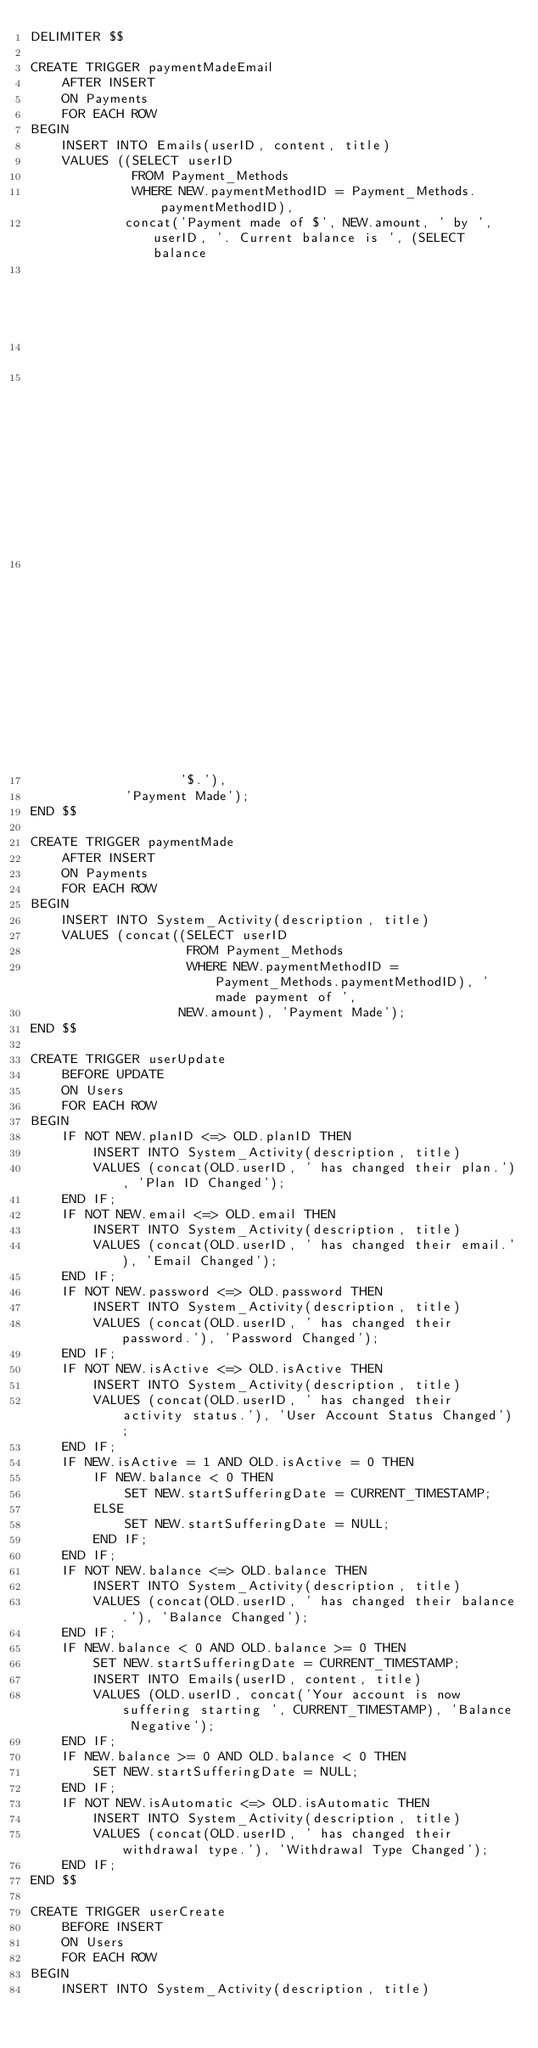<code> <loc_0><loc_0><loc_500><loc_500><_SQL_>DELIMITER $$

CREATE TRIGGER paymentMadeEmail
    AFTER INSERT
    ON Payments
    FOR EACH ROW
BEGIN
    INSERT INTO Emails(userID, content, title)
    VALUES ((SELECT userID
             FROM Payment_Methods
             WHERE NEW.paymentMethodID = Payment_Methods.paymentMethodID),
            concat('Payment made of $', NEW.amount, ' by ', userID, '. Current balance is ', (SELECT balance
                                                                                              FROM Users,
                                                                                                   Payment_Methods
                                                                                              WHERE NEW.paymentMethodID = Payment_Methods.paymentMethodID
                                                                                                AND Payment_Methods.userID = Users.userID),
                   '$.'),
            'Payment Made');
END $$

CREATE TRIGGER paymentMade
    AFTER INSERT
    ON Payments
    FOR EACH ROW
BEGIN
    INSERT INTO System_Activity(description, title)
    VALUES (concat((SELECT userID
                    FROM Payment_Methods
                    WHERE NEW.paymentMethodID = Payment_Methods.paymentMethodID), ' made payment of ',
                   NEW.amount), 'Payment Made');
END $$

CREATE TRIGGER userUpdate
    BEFORE UPDATE
    ON Users
    FOR EACH ROW
BEGIN
    IF NOT NEW.planID <=> OLD.planID THEN
        INSERT INTO System_Activity(description, title)
        VALUES (concat(OLD.userID, ' has changed their plan.'), 'Plan ID Changed');
    END IF;
    IF NOT NEW.email <=> OLD.email THEN
        INSERT INTO System_Activity(description, title)
        VALUES (concat(OLD.userID, ' has changed their email.'), 'Email Changed');
    END IF;
    IF NOT NEW.password <=> OLD.password THEN
        INSERT INTO System_Activity(description, title)
        VALUES (concat(OLD.userID, ' has changed their password.'), 'Password Changed');
    END IF;
    IF NOT NEW.isActive <=> OLD.isActive THEN
        INSERT INTO System_Activity(description, title)
        VALUES (concat(OLD.userID, ' has changed their activity status.'), 'User Account Status Changed');
    END IF;
    IF NEW.isActive = 1 AND OLD.isActive = 0 THEN
        IF NEW.balance < 0 THEN
            SET NEW.startSufferingDate = CURRENT_TIMESTAMP;
        ELSE
            SET NEW.startSufferingDate = NULL;
        END IF;
    END IF;
    IF NOT NEW.balance <=> OLD.balance THEN
        INSERT INTO System_Activity(description, title)
        VALUES (concat(OLD.userID, ' has changed their balance.'), 'Balance Changed');
    END IF;
    IF NEW.balance < 0 AND OLD.balance >= 0 THEN
        SET NEW.startSufferingDate = CURRENT_TIMESTAMP;
        INSERT INTO Emails(userID, content, title)
        VALUES (OLD.userID, concat('Your account is now suffering starting ', CURRENT_TIMESTAMP), 'Balance Negative');
    END IF;
    IF NEW.balance >= 0 AND OLD.balance < 0 THEN
        SET NEW.startSufferingDate = NULL;
    END IF;
    IF NOT NEW.isAutomatic <=> OLD.isAutomatic THEN
        INSERT INTO System_Activity(description, title)
        VALUES (concat(OLD.userID, ' has changed their withdrawal type.'), 'Withdrawal Type Changed');
    END IF;
END $$

CREATE TRIGGER userCreate
    BEFORE INSERT
    ON Users
    FOR EACH ROW
BEGIN
    INSERT INTO System_Activity(description, title)</code> 